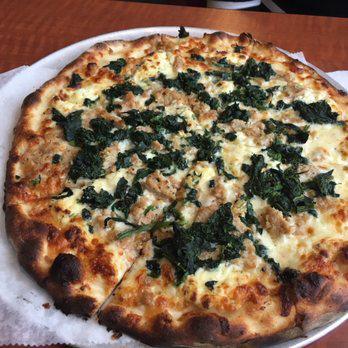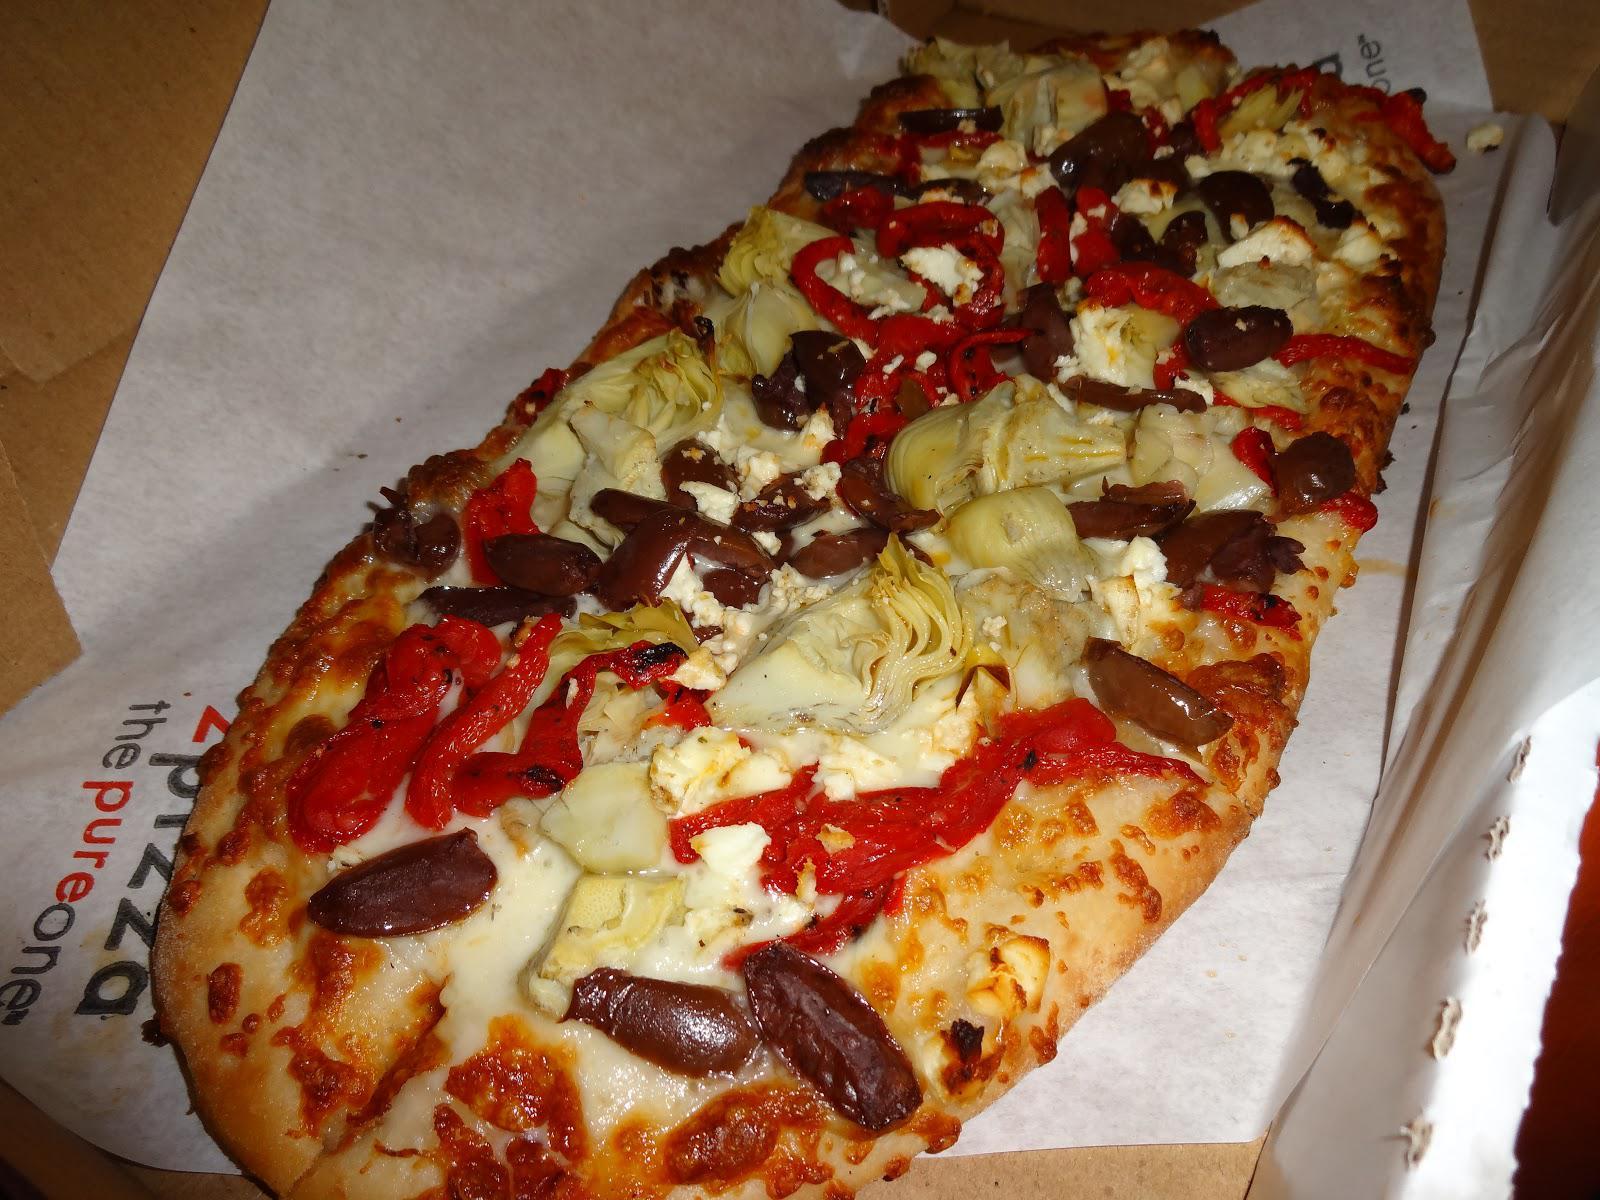The first image is the image on the left, the second image is the image on the right. Assess this claim about the two images: "A pizza has sliced tomatoes.". Correct or not? Answer yes or no. No. The first image is the image on the left, the second image is the image on the right. Evaluate the accuracy of this statement regarding the images: "One image shows a baked, brown-crusted pizza with no slices removed, and the other image shows less than an entire pizza.". Is it true? Answer yes or no. No. 